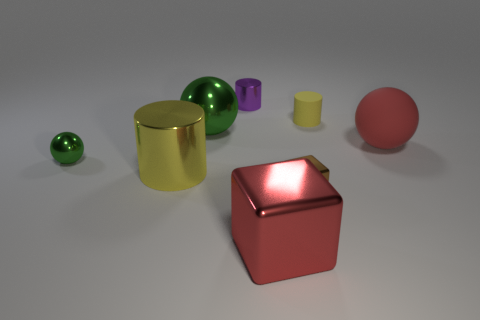The tiny thing that is both behind the tiny green ball and to the right of the big block is what color?
Ensure brevity in your answer.  Yellow. Is there a green thing made of the same material as the small yellow cylinder?
Your response must be concise. No. The brown object is what size?
Your answer should be very brief. Small. There is a green sphere in front of the large red object that is behind the big red block; what size is it?
Offer a terse response. Small. There is another yellow thing that is the same shape as the big yellow thing; what material is it?
Your response must be concise. Rubber. What number of tiny yellow matte things are there?
Your answer should be very brief. 1. What is the color of the small sphere in front of the big matte thing that is behind the yellow cylinder left of the big green ball?
Your answer should be compact. Green. Are there fewer tiny red metallic spheres than large rubber things?
Offer a very short reply. Yes. What color is the other tiny metallic object that is the same shape as the red metal object?
Offer a terse response. Brown. The big ball that is made of the same material as the large red cube is what color?
Ensure brevity in your answer.  Green. 